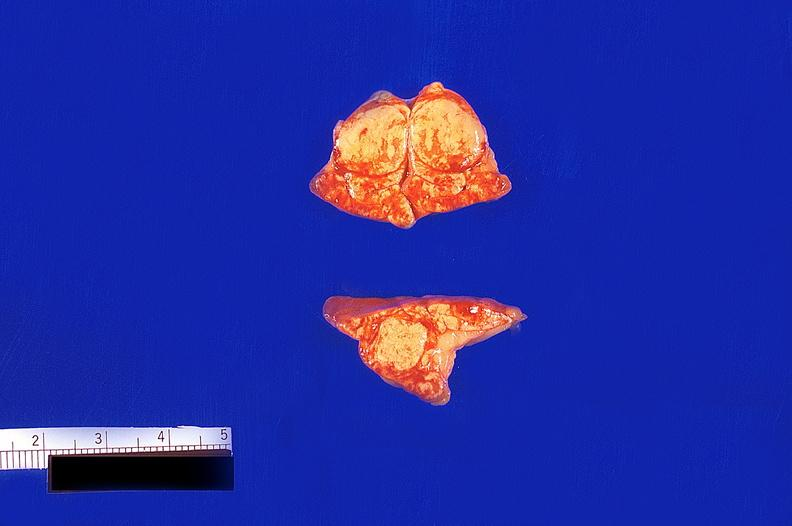where does this belong to?
Answer the question using a single word or phrase. Endocrine system 